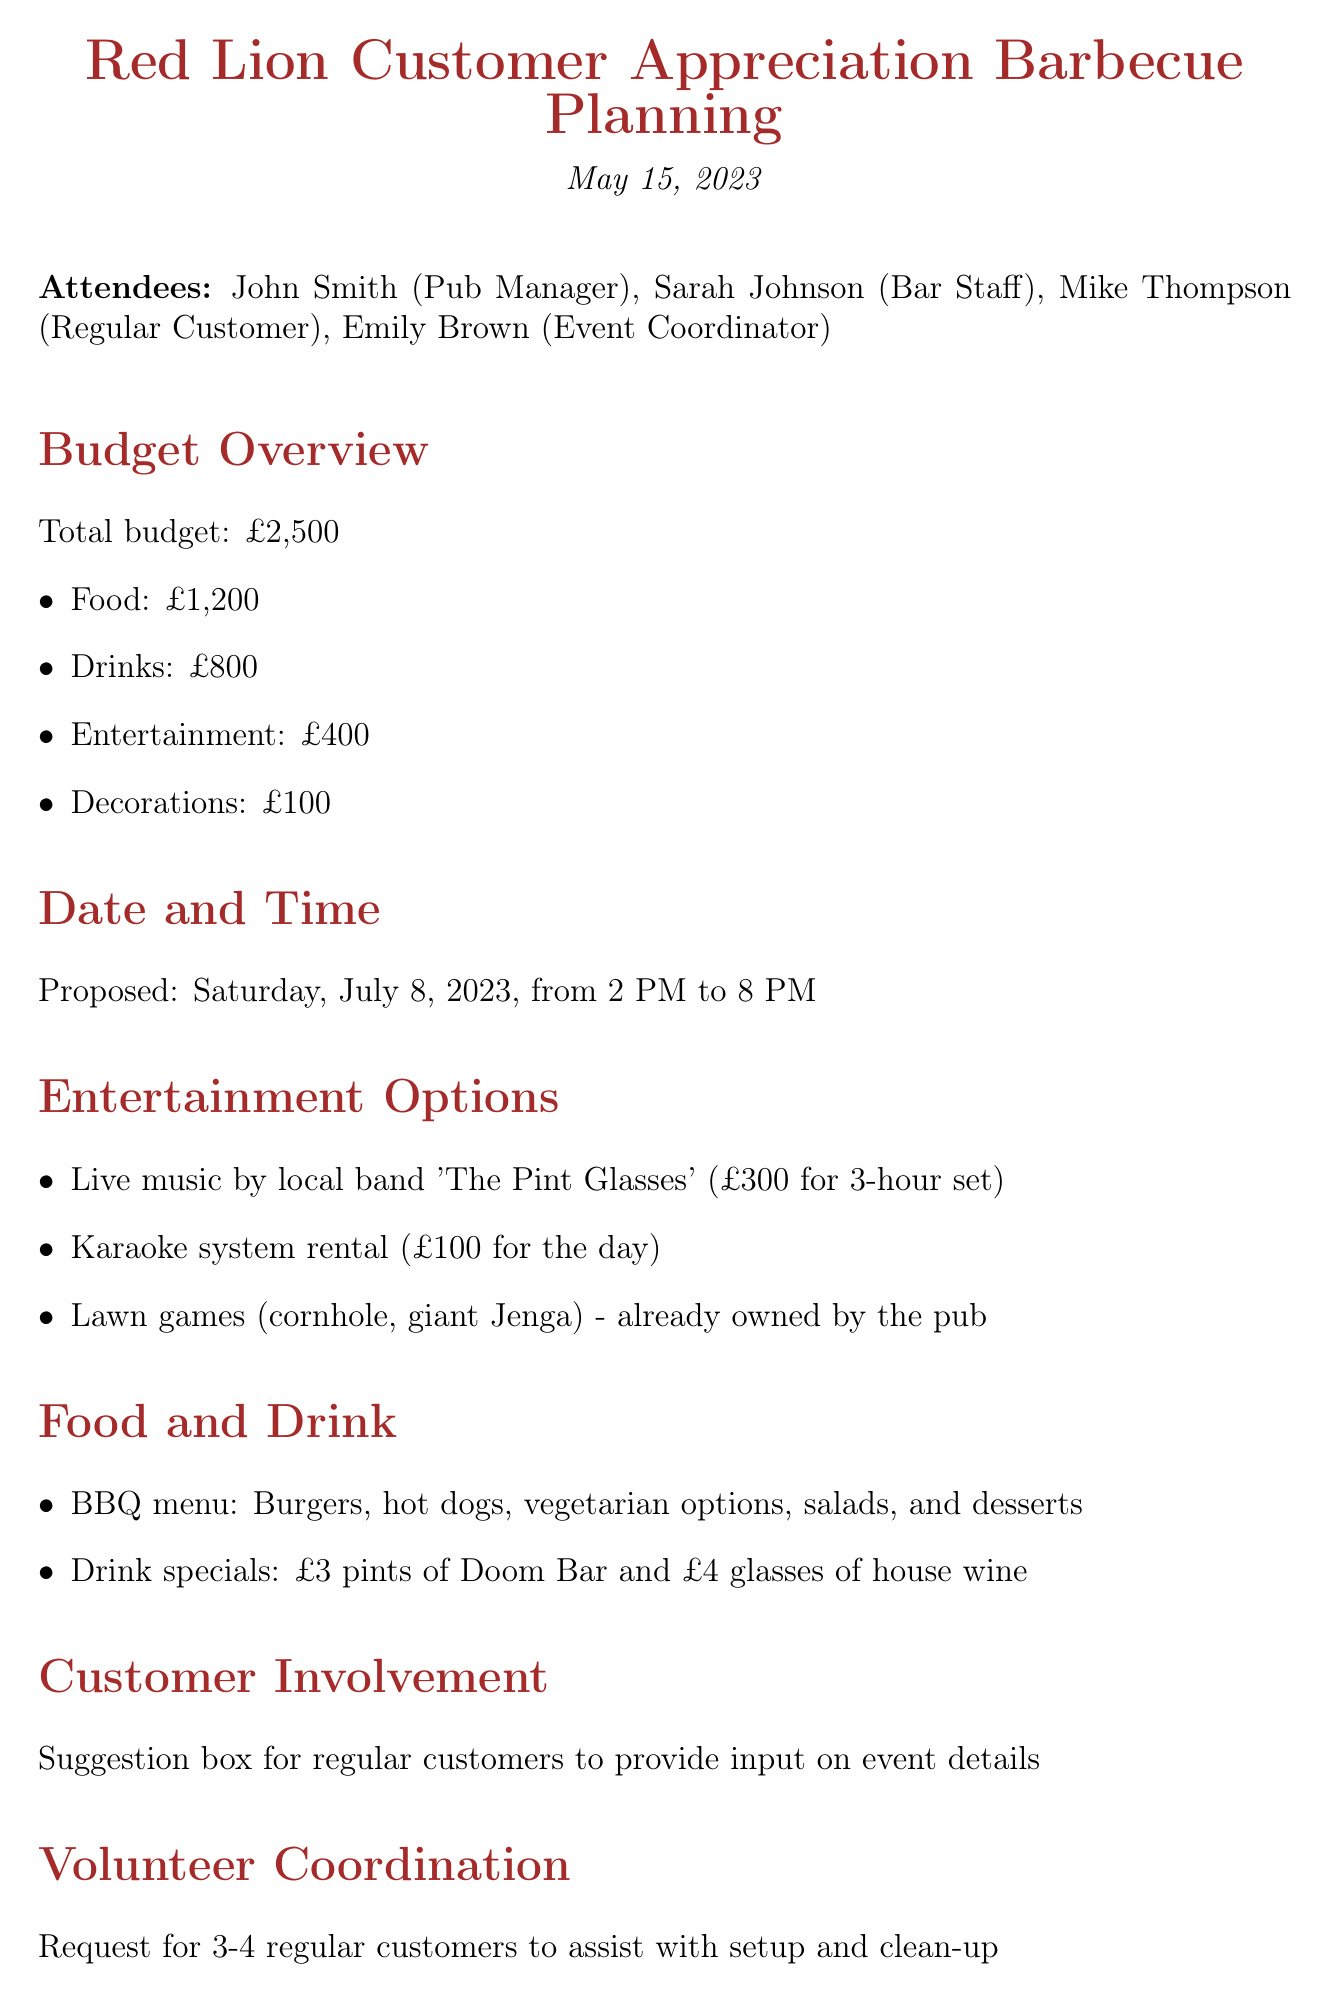What is the total budget for the barbecue? The total budget mentioned in the document is explicitly provided in the budget overview section.
Answer: £2,500 What is the proposed date for the event? The proposed date is clearly stated in the date and time section of the document.
Answer: Saturday, July 8, 2023 How much is allocated for entertainment? The document specifies the allocation for entertainment under the budget overview section.
Answer: £400 Who is responsible for booking entertainment? This responsibility is assigned to Emily in the action items section.
Answer: Emily What type of food will be served at the barbecue? The food options are listed in the food and drink section, detailing what will be available at the event.
Answer: Burgers, hot dogs, vegetarian options, salads, and desserts What is the cost of the karaoke system rental? The expense for the karaoke system is noted in the entertainment options section.
Answer: £100 How many regular customers are requested to assist with setup and clean-up? The volunteer coordination section states the number of volunteers needed explicitly.
Answer: 3-4 What drink special is mentioned for the event? The drink specials are detailed in the food and drink section, stating the prices.
Answer: £3 pints of Doom Bar and £4 glasses of house wine What is the name of the local band scheduled for live music? The document names the local band in the entertainment options section.
Answer: The Pint Glasses 